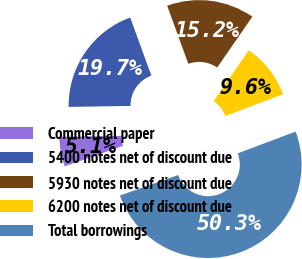<chart> <loc_0><loc_0><loc_500><loc_500><pie_chart><fcel>Commercial paper<fcel>5400 notes net of discount due<fcel>5930 notes net of discount due<fcel>6200 notes net of discount due<fcel>Total borrowings<nl><fcel>5.13%<fcel>19.7%<fcel>15.18%<fcel>9.65%<fcel>50.34%<nl></chart> 